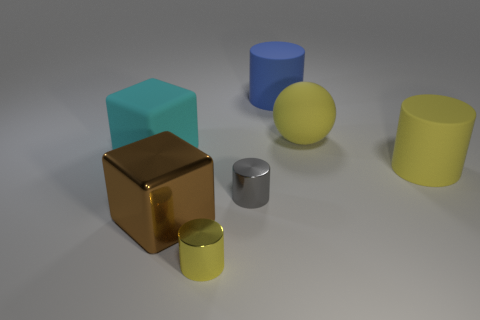Subtract all purple cubes. Subtract all gray spheres. How many cubes are left? 2 Add 1 gray shiny cylinders. How many objects exist? 8 Subtract all blocks. How many objects are left? 5 Add 4 large matte spheres. How many large matte spheres are left? 5 Add 6 small blue balls. How many small blue balls exist? 6 Subtract 0 cyan spheres. How many objects are left? 7 Subtract all shiny cubes. Subtract all shiny objects. How many objects are left? 3 